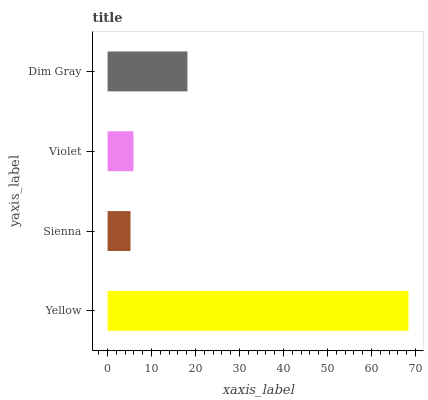Is Sienna the minimum?
Answer yes or no. Yes. Is Yellow the maximum?
Answer yes or no. Yes. Is Violet the minimum?
Answer yes or no. No. Is Violet the maximum?
Answer yes or no. No. Is Violet greater than Sienna?
Answer yes or no. Yes. Is Sienna less than Violet?
Answer yes or no. Yes. Is Sienna greater than Violet?
Answer yes or no. No. Is Violet less than Sienna?
Answer yes or no. No. Is Dim Gray the high median?
Answer yes or no. Yes. Is Violet the low median?
Answer yes or no. Yes. Is Yellow the high median?
Answer yes or no. No. Is Yellow the low median?
Answer yes or no. No. 